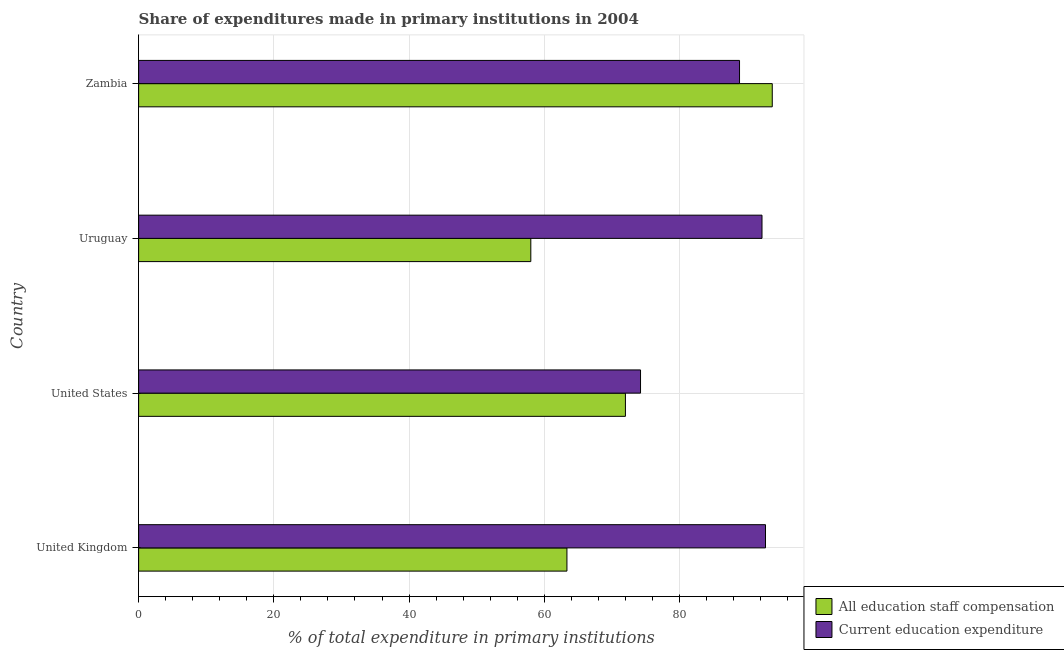How many different coloured bars are there?
Give a very brief answer. 2. How many bars are there on the 2nd tick from the top?
Offer a terse response. 2. What is the label of the 2nd group of bars from the top?
Provide a short and direct response. Uruguay. What is the expenditure in education in United Kingdom?
Your answer should be very brief. 92.73. Across all countries, what is the maximum expenditure in education?
Offer a terse response. 92.73. Across all countries, what is the minimum expenditure in education?
Give a very brief answer. 74.24. In which country was the expenditure in staff compensation maximum?
Offer a very short reply. Zambia. What is the total expenditure in education in the graph?
Your answer should be very brief. 348.06. What is the difference between the expenditure in staff compensation in United States and that in Uruguay?
Provide a short and direct response. 13.99. What is the difference between the expenditure in staff compensation in Zambia and the expenditure in education in United States?
Provide a succinct answer. 19.49. What is the average expenditure in education per country?
Your answer should be very brief. 87.02. What is the difference between the expenditure in education and expenditure in staff compensation in United States?
Your answer should be compact. 2.23. In how many countries, is the expenditure in education greater than 64 %?
Your response must be concise. 4. What is the ratio of the expenditure in education in United States to that in Uruguay?
Keep it short and to the point. 0.81. Is the difference between the expenditure in staff compensation in United Kingdom and Uruguay greater than the difference between the expenditure in education in United Kingdom and Uruguay?
Keep it short and to the point. Yes. What is the difference between the highest and the second highest expenditure in education?
Provide a short and direct response. 0.52. What is the difference between the highest and the lowest expenditure in education?
Make the answer very short. 18.49. In how many countries, is the expenditure in staff compensation greater than the average expenditure in staff compensation taken over all countries?
Provide a short and direct response. 2. What does the 2nd bar from the top in Uruguay represents?
Offer a very short reply. All education staff compensation. What does the 1st bar from the bottom in Uruguay represents?
Make the answer very short. All education staff compensation. Are all the bars in the graph horizontal?
Your answer should be compact. Yes. What is the difference between two consecutive major ticks on the X-axis?
Ensure brevity in your answer.  20. Does the graph contain any zero values?
Your answer should be compact. No. Where does the legend appear in the graph?
Your response must be concise. Bottom right. How many legend labels are there?
Offer a terse response. 2. What is the title of the graph?
Your answer should be very brief. Share of expenditures made in primary institutions in 2004. What is the label or title of the X-axis?
Give a very brief answer. % of total expenditure in primary institutions. What is the label or title of the Y-axis?
Provide a short and direct response. Country. What is the % of total expenditure in primary institutions in All education staff compensation in United Kingdom?
Your answer should be very brief. 63.36. What is the % of total expenditure in primary institutions of Current education expenditure in United Kingdom?
Provide a short and direct response. 92.73. What is the % of total expenditure in primary institutions in All education staff compensation in United States?
Provide a short and direct response. 72.01. What is the % of total expenditure in primary institutions of Current education expenditure in United States?
Provide a succinct answer. 74.24. What is the % of total expenditure in primary institutions in All education staff compensation in Uruguay?
Provide a short and direct response. 58.01. What is the % of total expenditure in primary institutions of Current education expenditure in Uruguay?
Provide a short and direct response. 92.21. What is the % of total expenditure in primary institutions of All education staff compensation in Zambia?
Offer a very short reply. 93.73. What is the % of total expenditure in primary institutions in Current education expenditure in Zambia?
Give a very brief answer. 88.89. Across all countries, what is the maximum % of total expenditure in primary institutions in All education staff compensation?
Your answer should be compact. 93.73. Across all countries, what is the maximum % of total expenditure in primary institutions in Current education expenditure?
Keep it short and to the point. 92.73. Across all countries, what is the minimum % of total expenditure in primary institutions of All education staff compensation?
Keep it short and to the point. 58.01. Across all countries, what is the minimum % of total expenditure in primary institutions of Current education expenditure?
Your answer should be compact. 74.24. What is the total % of total expenditure in primary institutions in All education staff compensation in the graph?
Your answer should be compact. 287.1. What is the total % of total expenditure in primary institutions of Current education expenditure in the graph?
Ensure brevity in your answer.  348.06. What is the difference between the % of total expenditure in primary institutions in All education staff compensation in United Kingdom and that in United States?
Your answer should be very brief. -8.65. What is the difference between the % of total expenditure in primary institutions of Current education expenditure in United Kingdom and that in United States?
Give a very brief answer. 18.49. What is the difference between the % of total expenditure in primary institutions of All education staff compensation in United Kingdom and that in Uruguay?
Your answer should be compact. 5.34. What is the difference between the % of total expenditure in primary institutions of Current education expenditure in United Kingdom and that in Uruguay?
Offer a very short reply. 0.52. What is the difference between the % of total expenditure in primary institutions of All education staff compensation in United Kingdom and that in Zambia?
Offer a terse response. -30.37. What is the difference between the % of total expenditure in primary institutions in Current education expenditure in United Kingdom and that in Zambia?
Your answer should be very brief. 3.84. What is the difference between the % of total expenditure in primary institutions of All education staff compensation in United States and that in Uruguay?
Ensure brevity in your answer.  13.99. What is the difference between the % of total expenditure in primary institutions of Current education expenditure in United States and that in Uruguay?
Your answer should be compact. -17.97. What is the difference between the % of total expenditure in primary institutions in All education staff compensation in United States and that in Zambia?
Make the answer very short. -21.72. What is the difference between the % of total expenditure in primary institutions in Current education expenditure in United States and that in Zambia?
Offer a very short reply. -14.65. What is the difference between the % of total expenditure in primary institutions in All education staff compensation in Uruguay and that in Zambia?
Provide a short and direct response. -35.72. What is the difference between the % of total expenditure in primary institutions in Current education expenditure in Uruguay and that in Zambia?
Offer a terse response. 3.32. What is the difference between the % of total expenditure in primary institutions in All education staff compensation in United Kingdom and the % of total expenditure in primary institutions in Current education expenditure in United States?
Offer a terse response. -10.89. What is the difference between the % of total expenditure in primary institutions in All education staff compensation in United Kingdom and the % of total expenditure in primary institutions in Current education expenditure in Uruguay?
Your response must be concise. -28.85. What is the difference between the % of total expenditure in primary institutions in All education staff compensation in United Kingdom and the % of total expenditure in primary institutions in Current education expenditure in Zambia?
Offer a terse response. -25.53. What is the difference between the % of total expenditure in primary institutions in All education staff compensation in United States and the % of total expenditure in primary institutions in Current education expenditure in Uruguay?
Make the answer very short. -20.2. What is the difference between the % of total expenditure in primary institutions of All education staff compensation in United States and the % of total expenditure in primary institutions of Current education expenditure in Zambia?
Your answer should be compact. -16.88. What is the difference between the % of total expenditure in primary institutions of All education staff compensation in Uruguay and the % of total expenditure in primary institutions of Current education expenditure in Zambia?
Your response must be concise. -30.88. What is the average % of total expenditure in primary institutions in All education staff compensation per country?
Provide a succinct answer. 71.78. What is the average % of total expenditure in primary institutions in Current education expenditure per country?
Offer a terse response. 87.02. What is the difference between the % of total expenditure in primary institutions in All education staff compensation and % of total expenditure in primary institutions in Current education expenditure in United Kingdom?
Offer a very short reply. -29.37. What is the difference between the % of total expenditure in primary institutions in All education staff compensation and % of total expenditure in primary institutions in Current education expenditure in United States?
Offer a very short reply. -2.24. What is the difference between the % of total expenditure in primary institutions of All education staff compensation and % of total expenditure in primary institutions of Current education expenditure in Uruguay?
Provide a short and direct response. -34.2. What is the difference between the % of total expenditure in primary institutions in All education staff compensation and % of total expenditure in primary institutions in Current education expenditure in Zambia?
Provide a short and direct response. 4.84. What is the ratio of the % of total expenditure in primary institutions in All education staff compensation in United Kingdom to that in United States?
Make the answer very short. 0.88. What is the ratio of the % of total expenditure in primary institutions of Current education expenditure in United Kingdom to that in United States?
Your answer should be compact. 1.25. What is the ratio of the % of total expenditure in primary institutions in All education staff compensation in United Kingdom to that in Uruguay?
Give a very brief answer. 1.09. What is the ratio of the % of total expenditure in primary institutions in Current education expenditure in United Kingdom to that in Uruguay?
Ensure brevity in your answer.  1.01. What is the ratio of the % of total expenditure in primary institutions in All education staff compensation in United Kingdom to that in Zambia?
Your answer should be very brief. 0.68. What is the ratio of the % of total expenditure in primary institutions of Current education expenditure in United Kingdom to that in Zambia?
Your response must be concise. 1.04. What is the ratio of the % of total expenditure in primary institutions in All education staff compensation in United States to that in Uruguay?
Your response must be concise. 1.24. What is the ratio of the % of total expenditure in primary institutions in Current education expenditure in United States to that in Uruguay?
Provide a succinct answer. 0.81. What is the ratio of the % of total expenditure in primary institutions of All education staff compensation in United States to that in Zambia?
Offer a terse response. 0.77. What is the ratio of the % of total expenditure in primary institutions of Current education expenditure in United States to that in Zambia?
Your answer should be compact. 0.84. What is the ratio of the % of total expenditure in primary institutions in All education staff compensation in Uruguay to that in Zambia?
Provide a short and direct response. 0.62. What is the ratio of the % of total expenditure in primary institutions of Current education expenditure in Uruguay to that in Zambia?
Keep it short and to the point. 1.04. What is the difference between the highest and the second highest % of total expenditure in primary institutions of All education staff compensation?
Give a very brief answer. 21.72. What is the difference between the highest and the second highest % of total expenditure in primary institutions of Current education expenditure?
Keep it short and to the point. 0.52. What is the difference between the highest and the lowest % of total expenditure in primary institutions in All education staff compensation?
Keep it short and to the point. 35.72. What is the difference between the highest and the lowest % of total expenditure in primary institutions of Current education expenditure?
Ensure brevity in your answer.  18.49. 